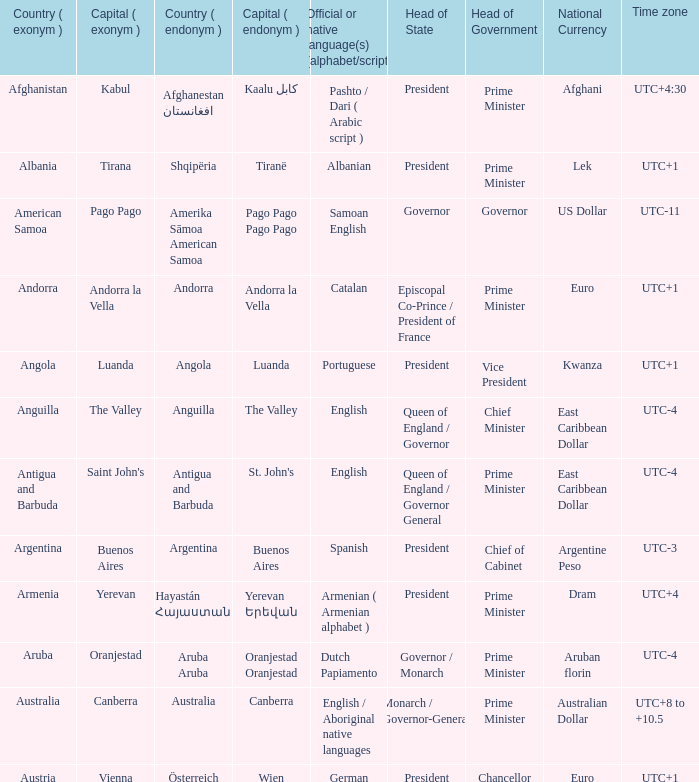What is the English name given to the city of St. John's? Saint John's. 